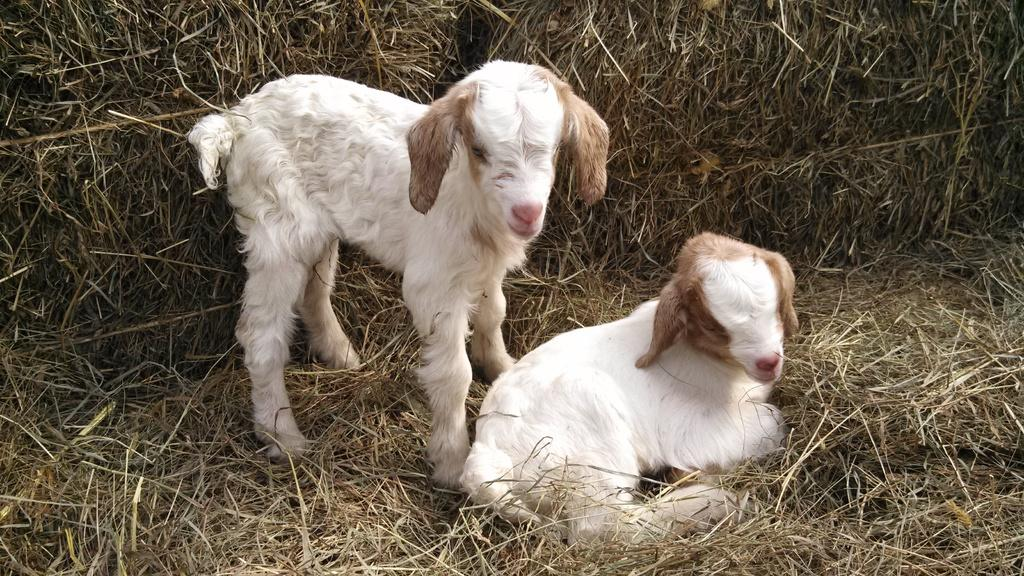What animals are present in the image? There are goats in the image. What is the terrain like where the goats are located? The goats are on dry grass. What can be seen in the background of the image? There are bunches of grass in the background of the image. Can you tell me the total cost of the items listed on the receipt in the image? There is no receipt present in the image; it features goats on dry grass with bunches of grass in the background. 